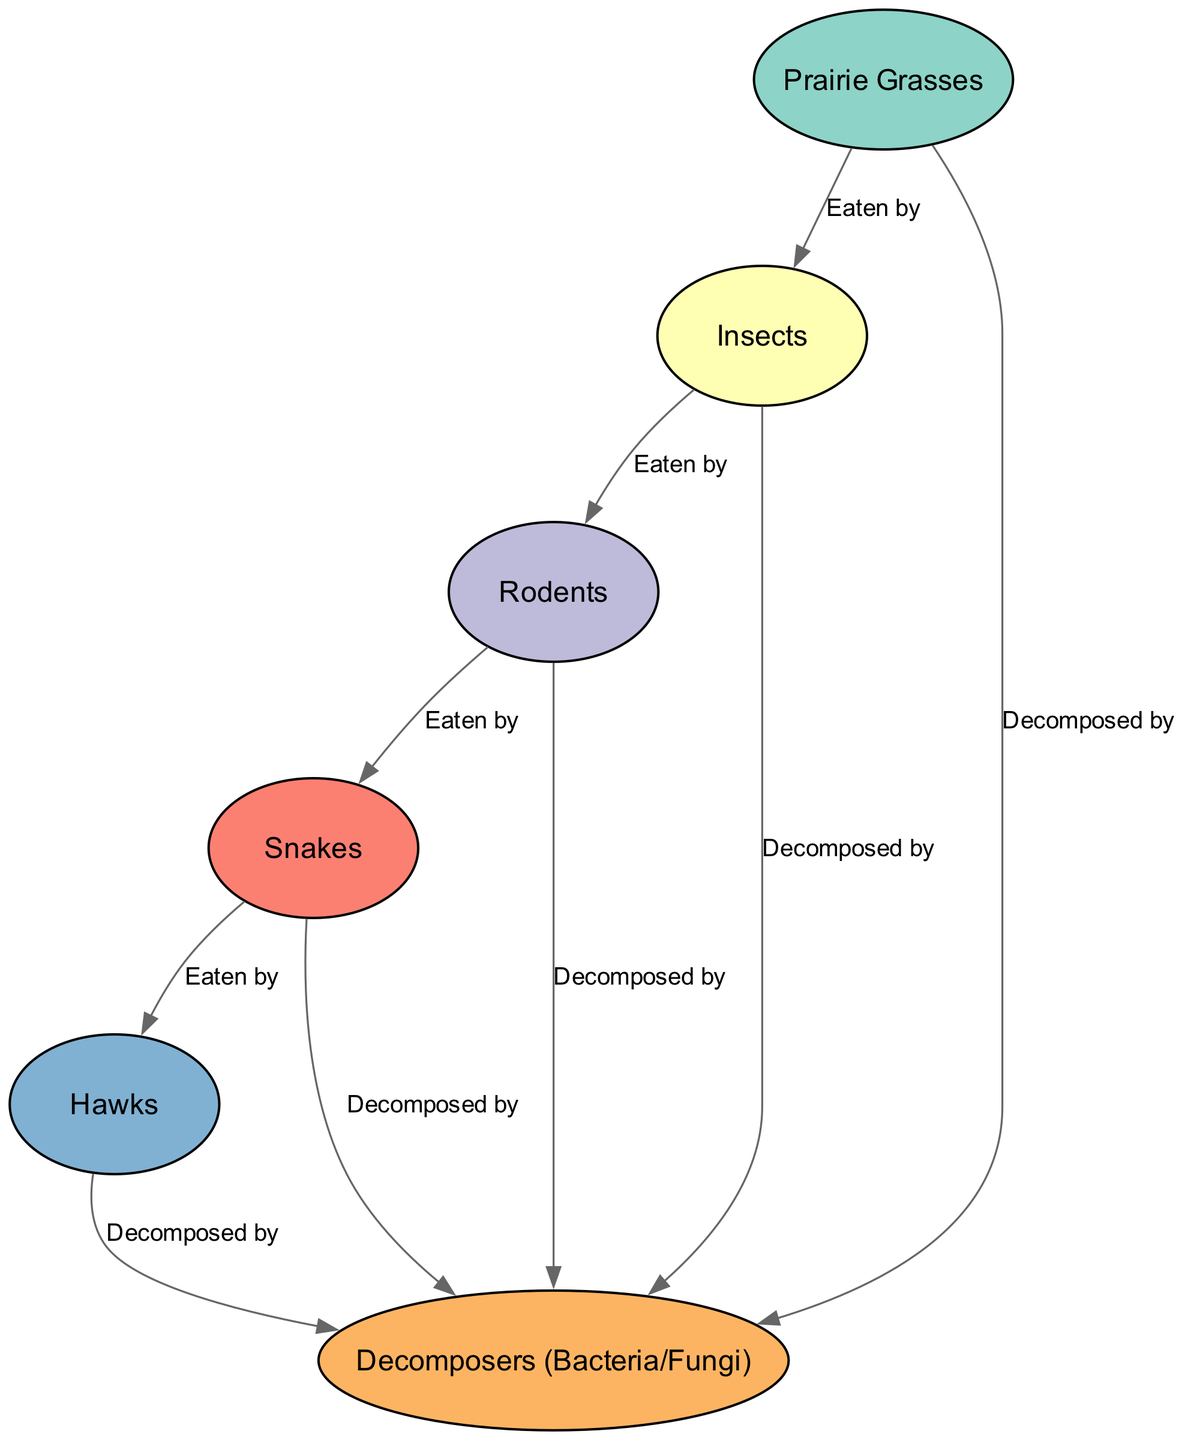What is the total number of nodes in the diagram? The diagram lists six distinct nodes, which include Prairie Grasses, Insects, Rodents, Snakes, Hawks, and Decomposers. Thus, counting these gives a total of six nodes.
Answer: 6 How many edges connect the Hawks in the diagram? The Hawks node has two edges connecting to the Decomposers, one for being eaten by Snakes and one for its decomposition. Therefore, it has a total of two edges.
Answer: 2 Which type of consumer is the Snakes node classified as? The Snakes node is classified as a Tertiary Consumer according to the diagram's node classifications.
Answer: Tertiary Consumer What is the relationship between Prairie Grasses and Insects? The diagram shows that Insects are eaten by Prairie Grasses, indicating a direct relationship where Prairie Grasses serve as a food source for Insects.
Answer: Eaten by How many decomposers are linked to Rodents? The diagram shows that Rodents have one edge leading to Decomposers for decomposition, indicating there is a single connection for this relationship.
Answer: 1 What type of organism is at the top of the food chain in this diagram? Hawks are indicated as the top of the food chain because they are the Quaternary Consumers, meaning they are at the highest trophic level depicted in the diagram.
Answer: Hawks Which nodes feed into Decomposers? The diagram has five nodes: Prairie Grasses, Insects, Rodents, Snakes, and Hawks that feed into the Decomposers, indicating multiple sources of organic matter for decomposition.
Answer: Prairie Grasses, Insects, Rodents, Snakes, Hawks What is the primary producer in the food chain? The primary producer in this food chain is the Prairie Grasses, which form the base of the food chain providing energy for primary consumers.
Answer: Prairie Grasses What type of consumer are Insects classified as? Insects are classified as Primary Consumers in the food chain as they directly consume producers like Prairie Grasses.
Answer: Primary Consumer 